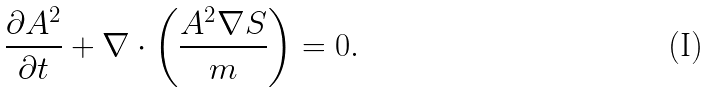<formula> <loc_0><loc_0><loc_500><loc_500>\frac { \partial A ^ { 2 } } { \partial t } + \nabla \cdot \left ( \frac { A ^ { 2 } \nabla S } { m } \right ) = 0 .</formula> 